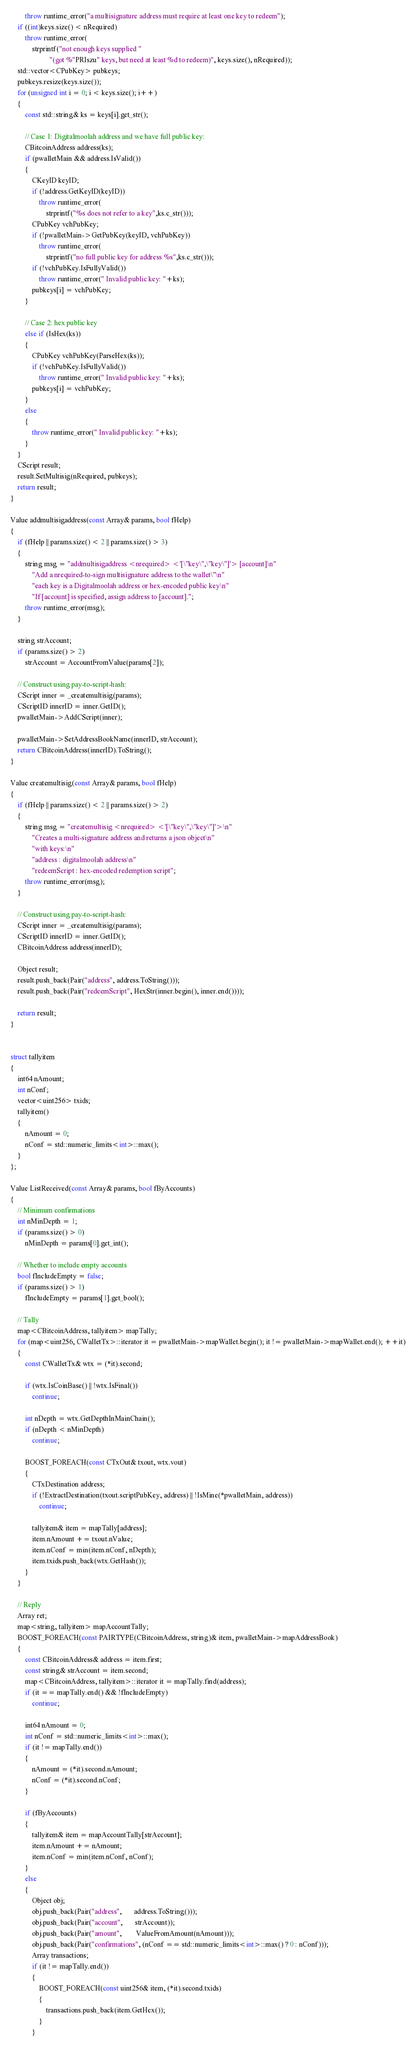Convert code to text. <code><loc_0><loc_0><loc_500><loc_500><_C++_>        throw runtime_error("a multisignature address must require at least one key to redeem");
    if ((int)keys.size() < nRequired)
        throw runtime_error(
            strprintf("not enough keys supplied "
                      "(got %"PRIszu" keys, but need at least %d to redeem)", keys.size(), nRequired));
    std::vector<CPubKey> pubkeys;
    pubkeys.resize(keys.size());
    for (unsigned int i = 0; i < keys.size(); i++)
    {
        const std::string& ks = keys[i].get_str();

        // Case 1: Digitalmoolah address and we have full public key:
        CBitcoinAddress address(ks);
        if (pwalletMain && address.IsValid())
        {
            CKeyID keyID;
            if (!address.GetKeyID(keyID))
                throw runtime_error(
                    strprintf("%s does not refer to a key",ks.c_str()));
            CPubKey vchPubKey;
            if (!pwalletMain->GetPubKey(keyID, vchPubKey))
                throw runtime_error(
                    strprintf("no full public key for address %s",ks.c_str()));
            if (!vchPubKey.IsFullyValid())
                throw runtime_error(" Invalid public key: "+ks);
            pubkeys[i] = vchPubKey;
        }

        // Case 2: hex public key
        else if (IsHex(ks))
        {
            CPubKey vchPubKey(ParseHex(ks));
            if (!vchPubKey.IsFullyValid())
                throw runtime_error(" Invalid public key: "+ks);
            pubkeys[i] = vchPubKey;
        }
        else
        {
            throw runtime_error(" Invalid public key: "+ks);
        }
    }
    CScript result;
    result.SetMultisig(nRequired, pubkeys);
    return result;
}

Value addmultisigaddress(const Array& params, bool fHelp)
{
    if (fHelp || params.size() < 2 || params.size() > 3)
    {
        string msg = "addmultisigaddress <nrequired> <'[\"key\",\"key\"]'> [account]\n"
            "Add a nrequired-to-sign multisignature address to the wallet\"\n"
            "each key is a Digitalmoolah address or hex-encoded public key\n"
            "If [account] is specified, assign address to [account].";
        throw runtime_error(msg);
    }

    string strAccount;
    if (params.size() > 2)
        strAccount = AccountFromValue(params[2]);

    // Construct using pay-to-script-hash:
    CScript inner = _createmultisig(params);
    CScriptID innerID = inner.GetID();
    pwalletMain->AddCScript(inner);

    pwalletMain->SetAddressBookName(innerID, strAccount);
    return CBitcoinAddress(innerID).ToString();
}

Value createmultisig(const Array& params, bool fHelp)
{
    if (fHelp || params.size() < 2 || params.size() > 2)
    {
        string msg = "createmultisig <nrequired> <'[\"key\",\"key\"]'>\n"
            "Creates a multi-signature address and returns a json object\n"
            "with keys:\n"
            "address : digitalmoolah address\n"
            "redeemScript : hex-encoded redemption script";
        throw runtime_error(msg);
    }

    // Construct using pay-to-script-hash:
    CScript inner = _createmultisig(params);
    CScriptID innerID = inner.GetID();
    CBitcoinAddress address(innerID);

    Object result;
    result.push_back(Pair("address", address.ToString()));
    result.push_back(Pair("redeemScript", HexStr(inner.begin(), inner.end())));

    return result;
}


struct tallyitem
{
    int64 nAmount;
    int nConf;
    vector<uint256> txids;
    tallyitem()
    {
        nAmount = 0;
        nConf = std::numeric_limits<int>::max();
    }
};

Value ListReceived(const Array& params, bool fByAccounts)
{
    // Minimum confirmations
    int nMinDepth = 1;
    if (params.size() > 0)
        nMinDepth = params[0].get_int();

    // Whether to include empty accounts
    bool fIncludeEmpty = false;
    if (params.size() > 1)
        fIncludeEmpty = params[1].get_bool();

    // Tally
    map<CBitcoinAddress, tallyitem> mapTally;
    for (map<uint256, CWalletTx>::iterator it = pwalletMain->mapWallet.begin(); it != pwalletMain->mapWallet.end(); ++it)
    {
        const CWalletTx& wtx = (*it).second;

        if (wtx.IsCoinBase() || !wtx.IsFinal())
            continue;

        int nDepth = wtx.GetDepthInMainChain();
        if (nDepth < nMinDepth)
            continue;

        BOOST_FOREACH(const CTxOut& txout, wtx.vout)
        {
            CTxDestination address;
            if (!ExtractDestination(txout.scriptPubKey, address) || !IsMine(*pwalletMain, address))
                continue;

            tallyitem& item = mapTally[address];
            item.nAmount += txout.nValue;
            item.nConf = min(item.nConf, nDepth);
            item.txids.push_back(wtx.GetHash());
        }
    }

    // Reply
    Array ret;
    map<string, tallyitem> mapAccountTally;
    BOOST_FOREACH(const PAIRTYPE(CBitcoinAddress, string)& item, pwalletMain->mapAddressBook)
    {
        const CBitcoinAddress& address = item.first;
        const string& strAccount = item.second;
        map<CBitcoinAddress, tallyitem>::iterator it = mapTally.find(address);
        if (it == mapTally.end() && !fIncludeEmpty)
            continue;

        int64 nAmount = 0;
        int nConf = std::numeric_limits<int>::max();
        if (it != mapTally.end())
        {
            nAmount = (*it).second.nAmount;
            nConf = (*it).second.nConf;
        }

        if (fByAccounts)
        {
            tallyitem& item = mapAccountTally[strAccount];
            item.nAmount += nAmount;
            item.nConf = min(item.nConf, nConf);
        }
        else
        {
            Object obj;
            obj.push_back(Pair("address",       address.ToString()));
            obj.push_back(Pair("account",       strAccount));
            obj.push_back(Pair("amount",        ValueFromAmount(nAmount)));
            obj.push_back(Pair("confirmations", (nConf == std::numeric_limits<int>::max() ? 0 : nConf)));
            Array transactions;
            if (it != mapTally.end())
            {
                BOOST_FOREACH(const uint256& item, (*it).second.txids)
                {
                    transactions.push_back(item.GetHex());
                }
            }</code> 